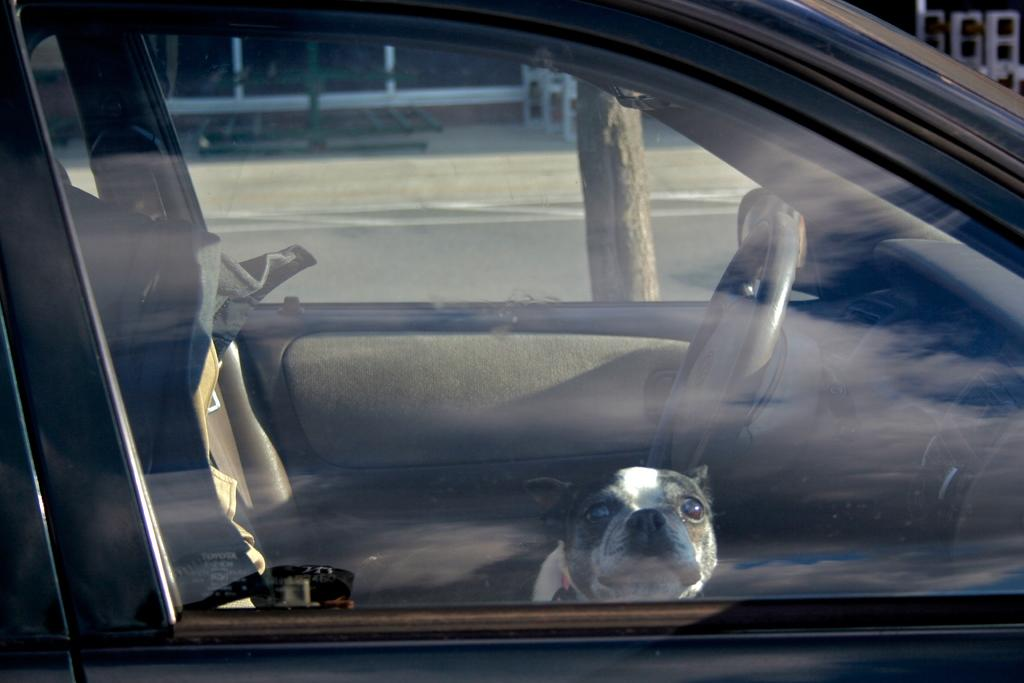What animal can be seen in the image? There is a dog in the image. Where is the dog located? The dog is sitting inside a car. What can be seen in the background of the image? There is a road visible in the image. How many lizards are sitting next to the dog in the car? There are no lizards present in the image; only the dog is visible inside the car. 